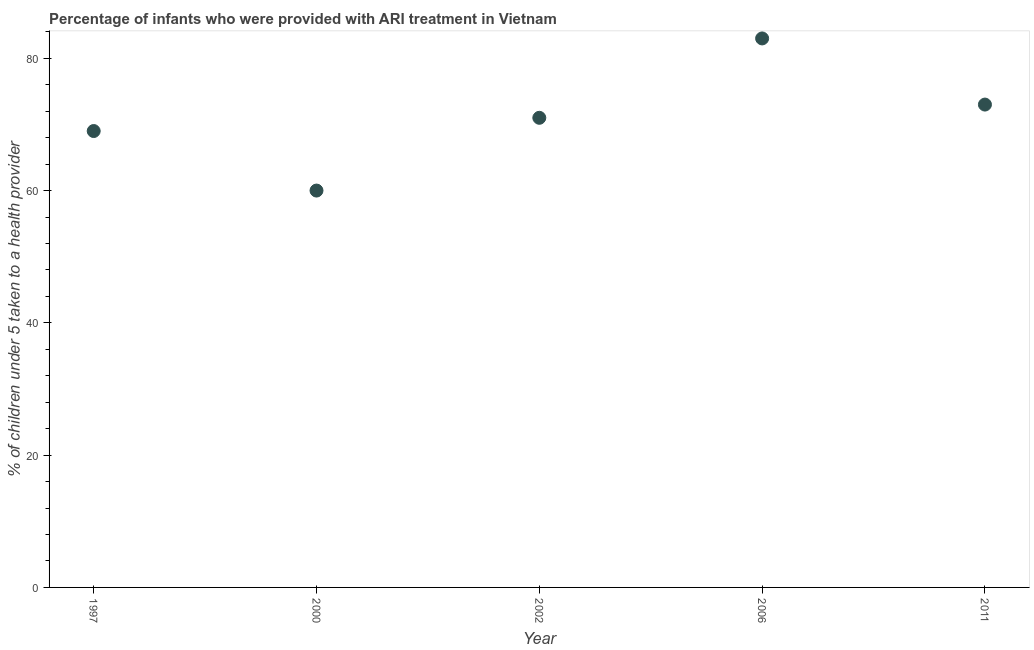What is the percentage of children who were provided with ari treatment in 2006?
Give a very brief answer. 83. Across all years, what is the maximum percentage of children who were provided with ari treatment?
Your answer should be compact. 83. Across all years, what is the minimum percentage of children who were provided with ari treatment?
Your response must be concise. 60. What is the sum of the percentage of children who were provided with ari treatment?
Keep it short and to the point. 356. What is the difference between the percentage of children who were provided with ari treatment in 2002 and 2006?
Provide a succinct answer. -12. What is the average percentage of children who were provided with ari treatment per year?
Provide a short and direct response. 71.2. What is the median percentage of children who were provided with ari treatment?
Your answer should be very brief. 71. Do a majority of the years between 1997 and 2000 (inclusive) have percentage of children who were provided with ari treatment greater than 12 %?
Ensure brevity in your answer.  Yes. What is the ratio of the percentage of children who were provided with ari treatment in 1997 to that in 2002?
Give a very brief answer. 0.97. Is the difference between the percentage of children who were provided with ari treatment in 2002 and 2006 greater than the difference between any two years?
Offer a terse response. No. What is the difference between the highest and the second highest percentage of children who were provided with ari treatment?
Keep it short and to the point. 10. Is the sum of the percentage of children who were provided with ari treatment in 2000 and 2006 greater than the maximum percentage of children who were provided with ari treatment across all years?
Offer a very short reply. Yes. What is the difference between the highest and the lowest percentage of children who were provided with ari treatment?
Offer a terse response. 23. How many dotlines are there?
Make the answer very short. 1. How many years are there in the graph?
Your response must be concise. 5. What is the title of the graph?
Your response must be concise. Percentage of infants who were provided with ARI treatment in Vietnam. What is the label or title of the Y-axis?
Offer a terse response. % of children under 5 taken to a health provider. What is the % of children under 5 taken to a health provider in 2000?
Offer a terse response. 60. What is the % of children under 5 taken to a health provider in 2006?
Keep it short and to the point. 83. What is the % of children under 5 taken to a health provider in 2011?
Ensure brevity in your answer.  73. What is the difference between the % of children under 5 taken to a health provider in 1997 and 2000?
Provide a succinct answer. 9. What is the difference between the % of children under 5 taken to a health provider in 2000 and 2011?
Ensure brevity in your answer.  -13. What is the difference between the % of children under 5 taken to a health provider in 2002 and 2006?
Your answer should be compact. -12. What is the difference between the % of children under 5 taken to a health provider in 2006 and 2011?
Provide a short and direct response. 10. What is the ratio of the % of children under 5 taken to a health provider in 1997 to that in 2000?
Your answer should be compact. 1.15. What is the ratio of the % of children under 5 taken to a health provider in 1997 to that in 2002?
Your answer should be compact. 0.97. What is the ratio of the % of children under 5 taken to a health provider in 1997 to that in 2006?
Make the answer very short. 0.83. What is the ratio of the % of children under 5 taken to a health provider in 1997 to that in 2011?
Your response must be concise. 0.94. What is the ratio of the % of children under 5 taken to a health provider in 2000 to that in 2002?
Give a very brief answer. 0.84. What is the ratio of the % of children under 5 taken to a health provider in 2000 to that in 2006?
Keep it short and to the point. 0.72. What is the ratio of the % of children under 5 taken to a health provider in 2000 to that in 2011?
Make the answer very short. 0.82. What is the ratio of the % of children under 5 taken to a health provider in 2002 to that in 2006?
Provide a succinct answer. 0.85. What is the ratio of the % of children under 5 taken to a health provider in 2006 to that in 2011?
Provide a succinct answer. 1.14. 